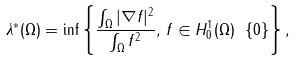Convert formula to latex. <formula><loc_0><loc_0><loc_500><loc_500>\lambda ^ { \ast } ( \Omega ) = \inf \left \{ \frac { \int _ { \Omega } | \nabla f | ^ { 2 } } { \int _ { \Omega } f ^ { 2 } } , \, f \in { H _ { 0 } ^ { 1 } ( \Omega ) \ \{ 0 \} } \right \} ,</formula> 